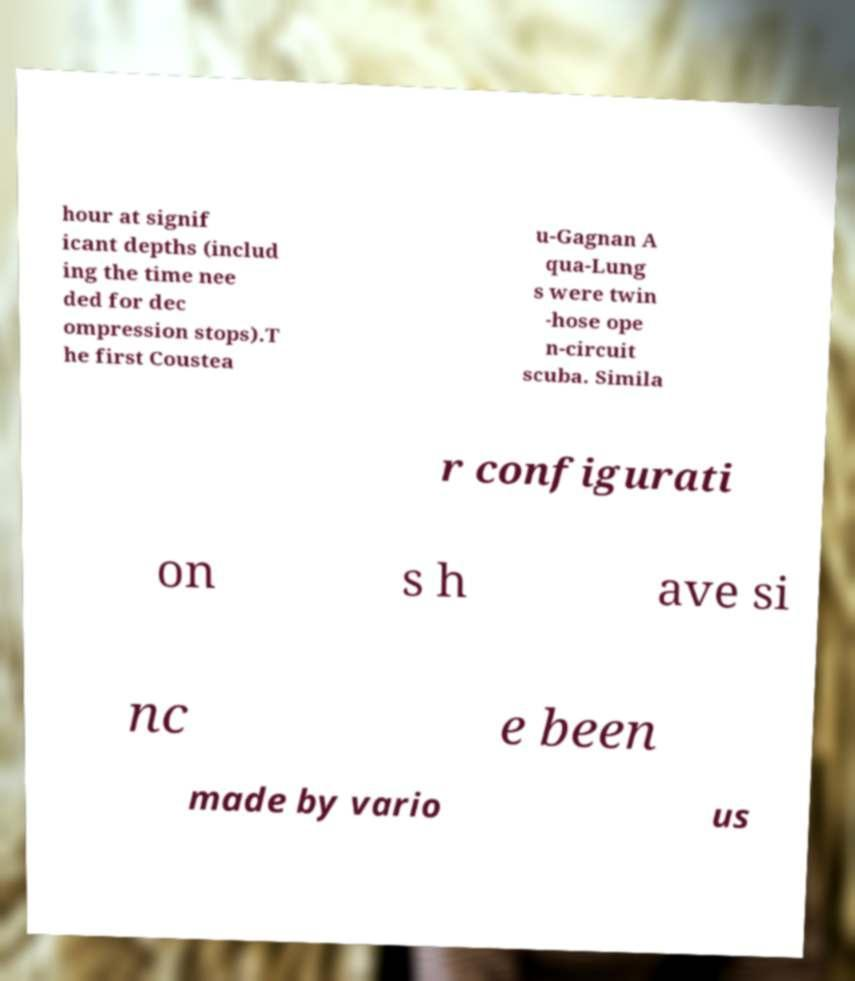Can you accurately transcribe the text from the provided image for me? hour at signif icant depths (includ ing the time nee ded for dec ompression stops).T he first Coustea u-Gagnan A qua-Lung s were twin -hose ope n-circuit scuba. Simila r configurati on s h ave si nc e been made by vario us 